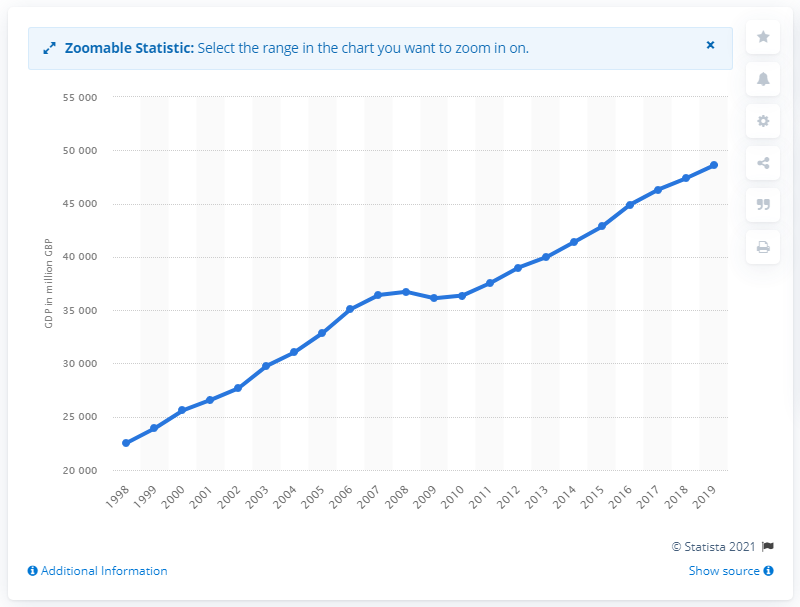Highlight a few significant elements in this photo. In 2019, the gross domestic product of Northern Ireland was 48,584. In the year 2018, the gross domestic product of Northern Ireland was 48.6 billion pounds. 